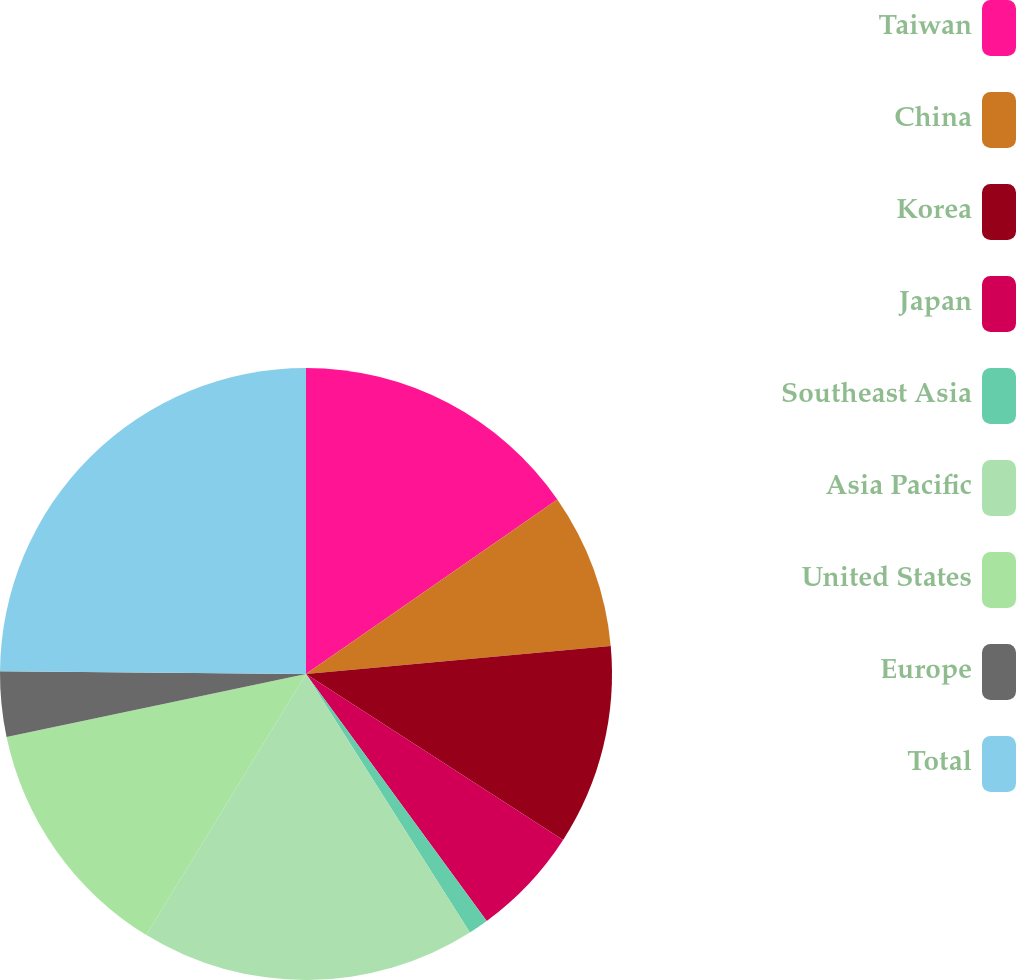Convert chart. <chart><loc_0><loc_0><loc_500><loc_500><pie_chart><fcel>Taiwan<fcel>China<fcel>Korea<fcel>Japan<fcel>Southeast Asia<fcel>Asia Pacific<fcel>United States<fcel>Europe<fcel>Total<nl><fcel>15.34%<fcel>8.2%<fcel>10.58%<fcel>5.82%<fcel>1.06%<fcel>17.73%<fcel>12.96%<fcel>3.44%<fcel>24.86%<nl></chart> 